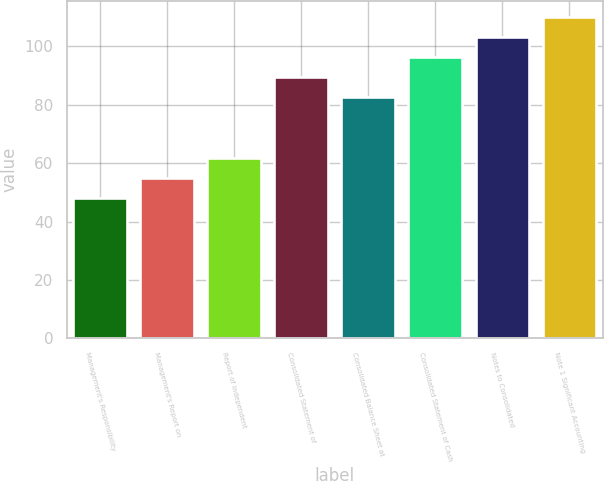<chart> <loc_0><loc_0><loc_500><loc_500><bar_chart><fcel>Management's Responsibility<fcel>Management's Report on<fcel>Report of Independent<fcel>Consolidated Statement of<fcel>Consolidated Balance Sheet at<fcel>Consolidated Statement of Cash<fcel>Notes to Consolidated<fcel>Note 1 Significant Accounting<nl><fcel>48<fcel>54.9<fcel>61.8<fcel>89.4<fcel>82.5<fcel>96.3<fcel>103.2<fcel>110.1<nl></chart> 